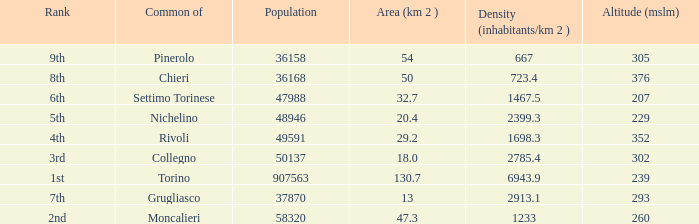What rank is the common with an area of 47.3 km^2? 2nd. 